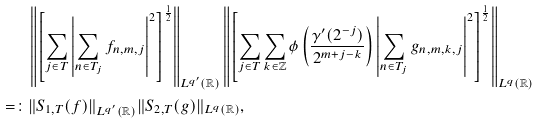<formula> <loc_0><loc_0><loc_500><loc_500>& \left \| \left [ \sum _ { j \in T } \left | \sum _ { n \in T _ { j } } f _ { n , m , j } \right | ^ { 2 } \right ] ^ { \frac { 1 } { 2 } } \right \| _ { L ^ { q ^ { \prime } } ( \mathbb { R } ) } \left \| \left [ \sum _ { j \in T } \sum _ { k \in \mathbb { Z } } \phi \left ( \frac { \gamma ^ { \prime } ( 2 ^ { - j } ) } { 2 ^ { m + j - k } } \right ) \left | \sum _ { n \in T _ { j } } g _ { n , m , k , j } \right | ^ { 2 } \right ] ^ { \frac { 1 } { 2 } } \right \| _ { L ^ { q } ( \mathbb { R } ) } \\ = \colon & \| S _ { 1 , T } ( f ) \| _ { L ^ { q ^ { \prime } } ( \mathbb { R } ) } \| S _ { 2 , T } ( g ) \| _ { L ^ { q } ( \mathbb { R } ) } ,</formula> 